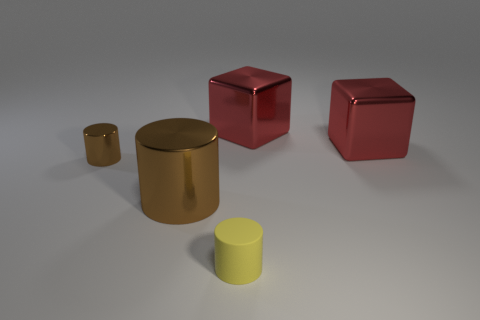Add 4 blocks. How many objects exist? 9 Subtract all blocks. How many objects are left? 3 Add 2 big brown things. How many big brown things are left? 3 Add 3 gray shiny cubes. How many gray shiny cubes exist? 3 Subtract 0 gray cubes. How many objects are left? 5 Subtract all green matte blocks. Subtract all big brown objects. How many objects are left? 4 